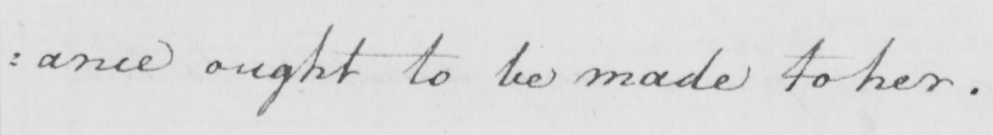Please transcribe the handwritten text in this image. : ance ought to be made to her . 